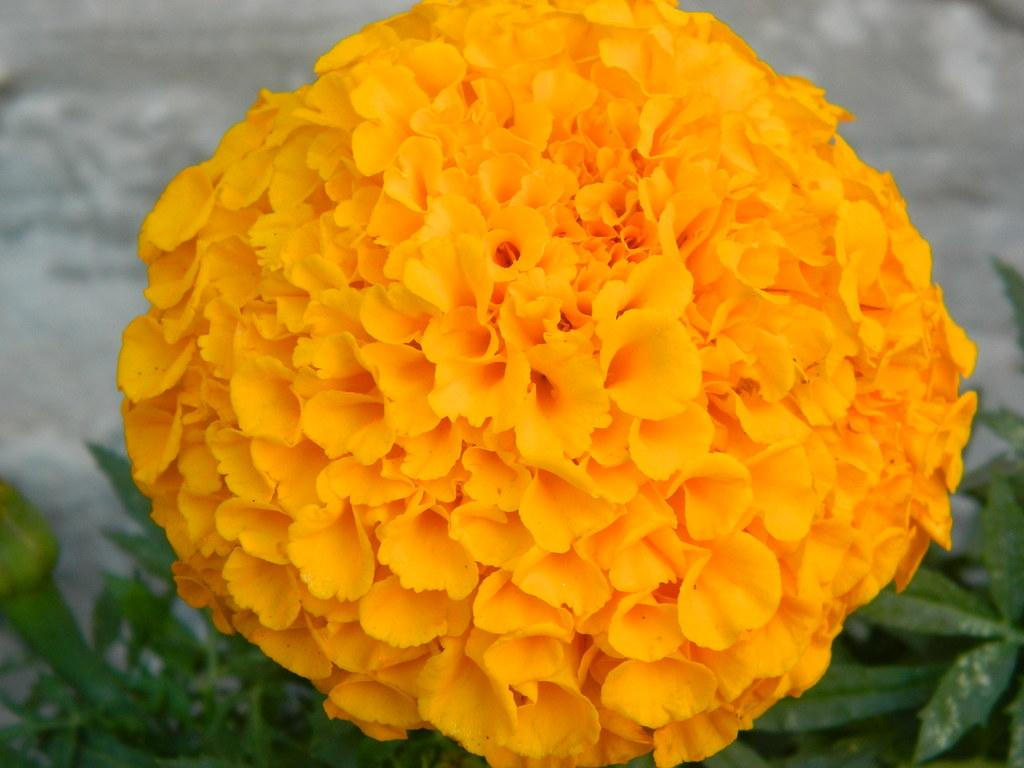What type of flower can be seen in the picture? There is a yellow flower in the picture. What other plants are present in the image? There are plants at the bottom of the picture. How would you describe the background of the picture? The background of the picture is grey and blurred. How many facts can be blown away by the wind in the picture? There are no facts present in the image, as facts are not physical objects that can be affected by the wind. 